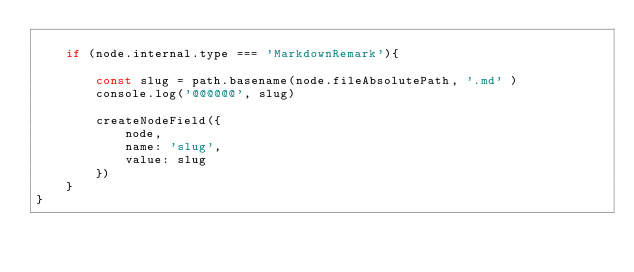<code> <loc_0><loc_0><loc_500><loc_500><_JavaScript_>
    if (node.internal.type === 'MarkdownRemark'){

        const slug = path.basename(node.fileAbsolutePath, '.md' )
        console.log('@@@@@@', slug)

        createNodeField({
            node,
            name: 'slug',
            value: slug
        })
    }
}
</code> 